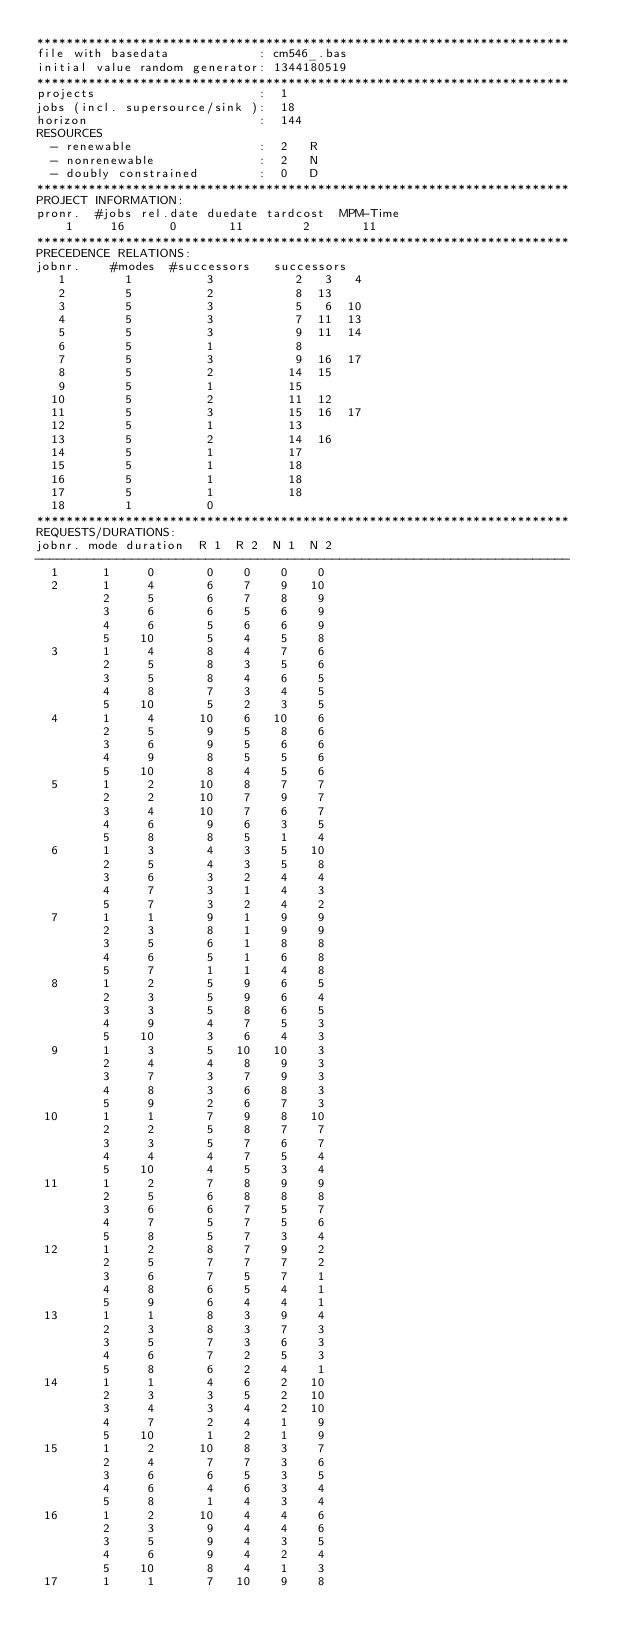Convert code to text. <code><loc_0><loc_0><loc_500><loc_500><_ObjectiveC_>************************************************************************
file with basedata            : cm546_.bas
initial value random generator: 1344180519
************************************************************************
projects                      :  1
jobs (incl. supersource/sink ):  18
horizon                       :  144
RESOURCES
  - renewable                 :  2   R
  - nonrenewable              :  2   N
  - doubly constrained        :  0   D
************************************************************************
PROJECT INFORMATION:
pronr.  #jobs rel.date duedate tardcost  MPM-Time
    1     16      0       11        2       11
************************************************************************
PRECEDENCE RELATIONS:
jobnr.    #modes  #successors   successors
   1        1          3           2   3   4
   2        5          2           8  13
   3        5          3           5   6  10
   4        5          3           7  11  13
   5        5          3           9  11  14
   6        5          1           8
   7        5          3           9  16  17
   8        5          2          14  15
   9        5          1          15
  10        5          2          11  12
  11        5          3          15  16  17
  12        5          1          13
  13        5          2          14  16
  14        5          1          17
  15        5          1          18
  16        5          1          18
  17        5          1          18
  18        1          0        
************************************************************************
REQUESTS/DURATIONS:
jobnr. mode duration  R 1  R 2  N 1  N 2
------------------------------------------------------------------------
  1      1     0       0    0    0    0
  2      1     4       6    7    9   10
         2     5       6    7    8    9
         3     6       6    5    6    9
         4     6       5    6    6    9
         5    10       5    4    5    8
  3      1     4       8    4    7    6
         2     5       8    3    5    6
         3     5       8    4    6    5
         4     8       7    3    4    5
         5    10       5    2    3    5
  4      1     4      10    6   10    6
         2     5       9    5    8    6
         3     6       9    5    6    6
         4     9       8    5    5    6
         5    10       8    4    5    6
  5      1     2      10    8    7    7
         2     2      10    7    9    7
         3     4      10    7    6    7
         4     6       9    6    3    5
         5     8       8    5    1    4
  6      1     3       4    3    5   10
         2     5       4    3    5    8
         3     6       3    2    4    4
         4     7       3    1    4    3
         5     7       3    2    4    2
  7      1     1       9    1    9    9
         2     3       8    1    9    9
         3     5       6    1    8    8
         4     6       5    1    6    8
         5     7       1    1    4    8
  8      1     2       5    9    6    5
         2     3       5    9    6    4
         3     3       5    8    6    5
         4     9       4    7    5    3
         5    10       3    6    4    3
  9      1     3       5   10   10    3
         2     4       4    8    9    3
         3     7       3    7    9    3
         4     8       3    6    8    3
         5     9       2    6    7    3
 10      1     1       7    9    8   10
         2     2       5    8    7    7
         3     3       5    7    6    7
         4     4       4    7    5    4
         5    10       4    5    3    4
 11      1     2       7    8    9    9
         2     5       6    8    8    8
         3     6       6    7    5    7
         4     7       5    7    5    6
         5     8       5    7    3    4
 12      1     2       8    7    9    2
         2     5       7    7    7    2
         3     6       7    5    7    1
         4     8       6    5    4    1
         5     9       6    4    4    1
 13      1     1       8    3    9    4
         2     3       8    3    7    3
         3     5       7    3    6    3
         4     6       7    2    5    3
         5     8       6    2    4    1
 14      1     1       4    6    2   10
         2     3       3    5    2   10
         3     4       3    4    2   10
         4     7       2    4    1    9
         5    10       1    2    1    9
 15      1     2      10    8    3    7
         2     4       7    7    3    6
         3     6       6    5    3    5
         4     6       4    6    3    4
         5     8       1    4    3    4
 16      1     2      10    4    4    6
         2     3       9    4    4    6
         3     5       9    4    3    5
         4     6       9    4    2    4
         5    10       8    4    1    3
 17      1     1       7   10    9    8</code> 